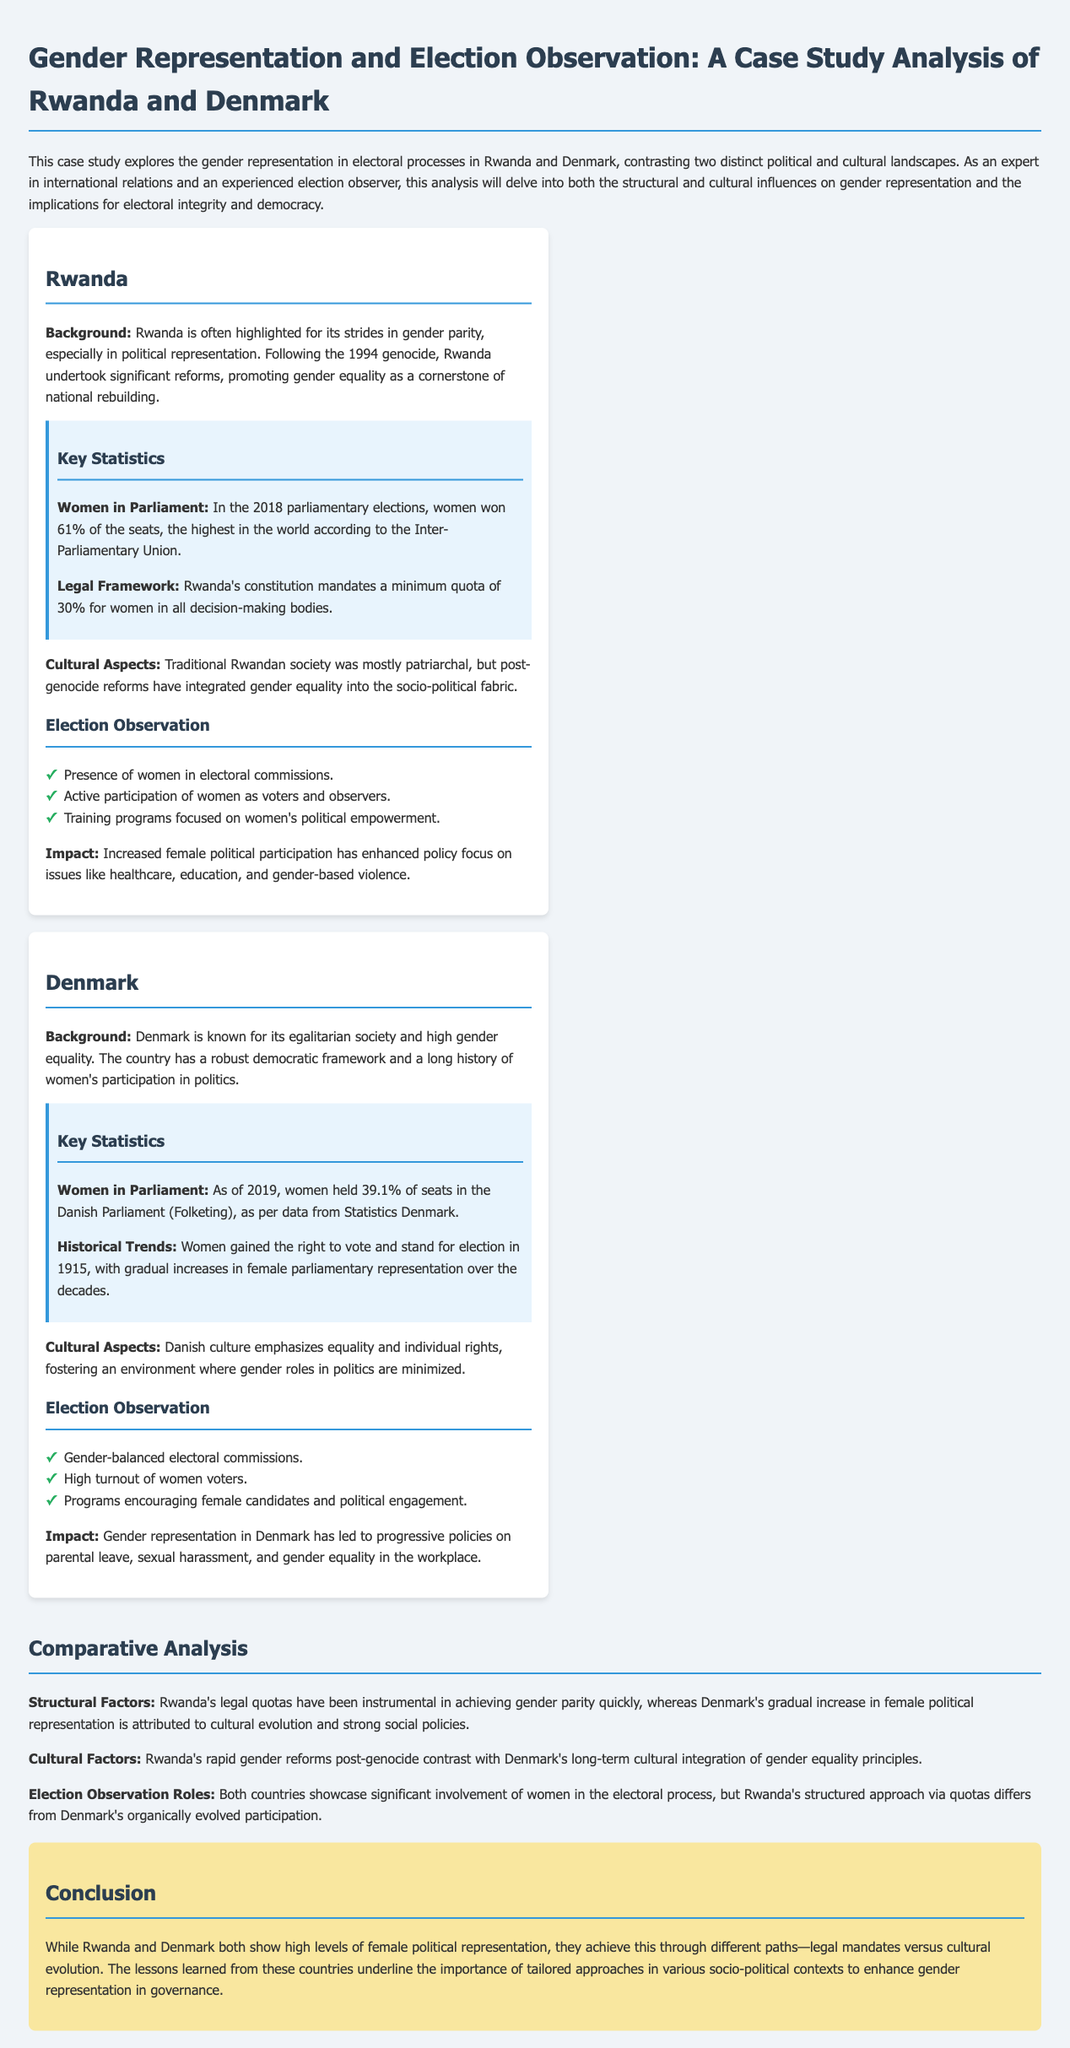what percentage of seats do women hold in the Rwandan Parliament as of 2018? In the 2018 parliamentary elections, women won 61% of the seats in Rwanda, which is noted in the document.
Answer: 61% what is the minimum quota for women in decision-making bodies in Rwanda's constitution? The document states that Rwanda's constitution mandates a minimum quota of 30% for women in all decision-making bodies.
Answer: 30% what percentage of seats do women hold in the Danish Parliament as of 2019? According to the document, as of 2019, women held 39.1% of seats in the Danish Parliament (Folketing).
Answer: 39.1% when did women gain the right to vote in Denmark? The document indicates that women gained the right to vote and stand for election in Denmark in 1915.
Answer: 1915 what structural factor contributed to Rwanda's rapid gender parity? The document indicates that Rwanda's legal quotas have been instrumental in achieving gender parity quickly.
Answer: Legal quotas how does Rwanda's approach to gender representation differ from Denmark's? The document highlights that Rwanda's structured approach via quotas differs from Denmark's organically evolved participation in gender representation.
Answer: Structured approach what is a key cultural aspect that influences gender representation in Denmark? The document mentions that Danish culture emphasizes equality and individual rights, influencing gender representation positively.
Answer: Equality and individual rights what impact has increased female political participation in Rwanda had? The document states that increased female political participation has enhanced policy focus on issues like healthcare, education, and gender-based violence.
Answer: Healthcare, education, gender-based violence how does the document classify itself? The title and content indicate that this is a case study analysis contrasting gender representation in Rwanda and Denmark.
Answer: Case study analysis 